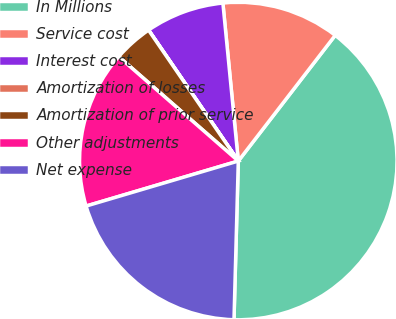Convert chart. <chart><loc_0><loc_0><loc_500><loc_500><pie_chart><fcel>In Millions<fcel>Service cost<fcel>Interest cost<fcel>Amortization of losses<fcel>Amortization of prior service<fcel>Other adjustments<fcel>Net expense<nl><fcel>39.98%<fcel>12.0%<fcel>8.01%<fcel>0.01%<fcel>4.01%<fcel>16.0%<fcel>19.99%<nl></chart> 